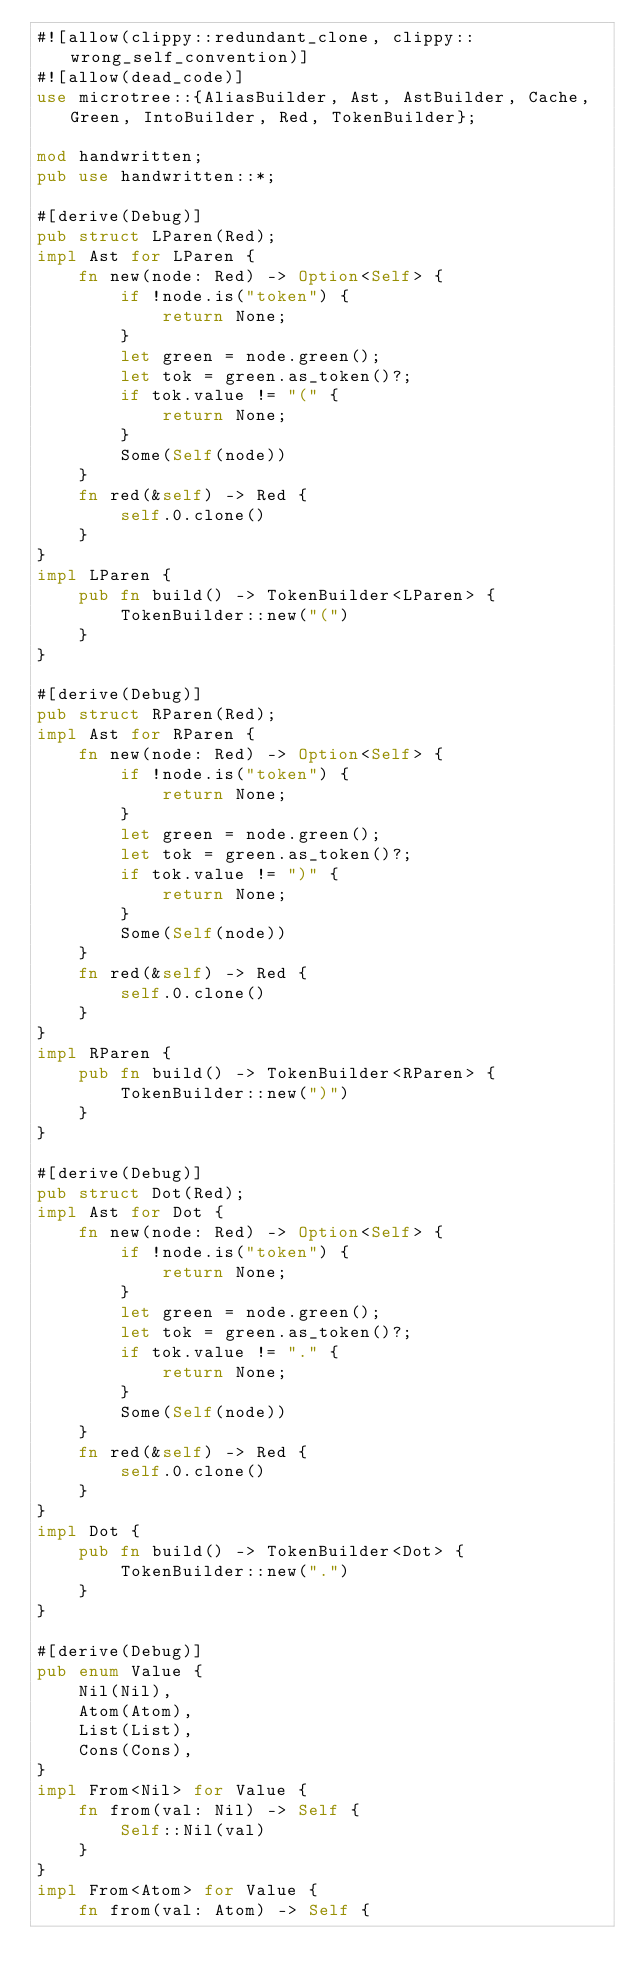Convert code to text. <code><loc_0><loc_0><loc_500><loc_500><_Rust_>#![allow(clippy::redundant_clone, clippy::wrong_self_convention)]
#![allow(dead_code)]
use microtree::{AliasBuilder, Ast, AstBuilder, Cache, Green, IntoBuilder, Red, TokenBuilder};

mod handwritten;
pub use handwritten::*;

#[derive(Debug)]
pub struct LParen(Red);
impl Ast for LParen {
    fn new(node: Red) -> Option<Self> {
        if !node.is("token") {
            return None;
        }
        let green = node.green();
        let tok = green.as_token()?;
        if tok.value != "(" {
            return None;
        }
        Some(Self(node))
    }
    fn red(&self) -> Red {
        self.0.clone()
    }
}
impl LParen {
    pub fn build() -> TokenBuilder<LParen> {
        TokenBuilder::new("(")
    }
}

#[derive(Debug)]
pub struct RParen(Red);
impl Ast for RParen {
    fn new(node: Red) -> Option<Self> {
        if !node.is("token") {
            return None;
        }
        let green = node.green();
        let tok = green.as_token()?;
        if tok.value != ")" {
            return None;
        }
        Some(Self(node))
    }
    fn red(&self) -> Red {
        self.0.clone()
    }
}
impl RParen {
    pub fn build() -> TokenBuilder<RParen> {
        TokenBuilder::new(")")
    }
}

#[derive(Debug)]
pub struct Dot(Red);
impl Ast for Dot {
    fn new(node: Red) -> Option<Self> {
        if !node.is("token") {
            return None;
        }
        let green = node.green();
        let tok = green.as_token()?;
        if tok.value != "." {
            return None;
        }
        Some(Self(node))
    }
    fn red(&self) -> Red {
        self.0.clone()
    }
}
impl Dot {
    pub fn build() -> TokenBuilder<Dot> {
        TokenBuilder::new(".")
    }
}

#[derive(Debug)]
pub enum Value {
    Nil(Nil),
    Atom(Atom),
    List(List),
    Cons(Cons),
}
impl From<Nil> for Value {
    fn from(val: Nil) -> Self {
        Self::Nil(val)
    }
}
impl From<Atom> for Value {
    fn from(val: Atom) -> Self {</code> 